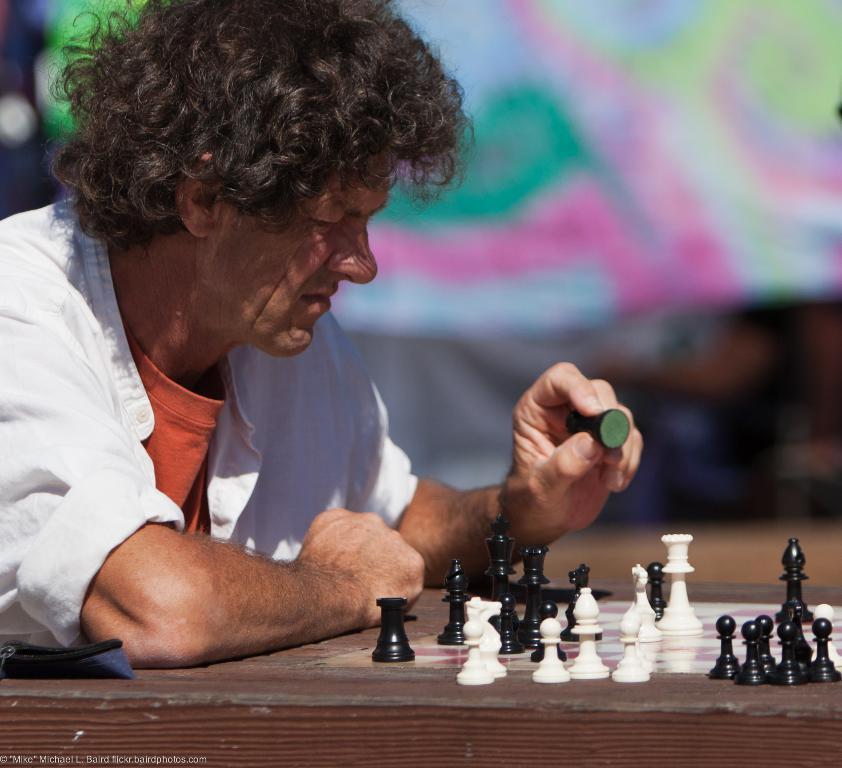Please provide a concise description of this image. On the left side, there is a person in white color shirt, holding a black color chess piece with one hand and keeping the other hand on a table, on which there is a chess board, on which there are chess pieces. And the background is blurred. 